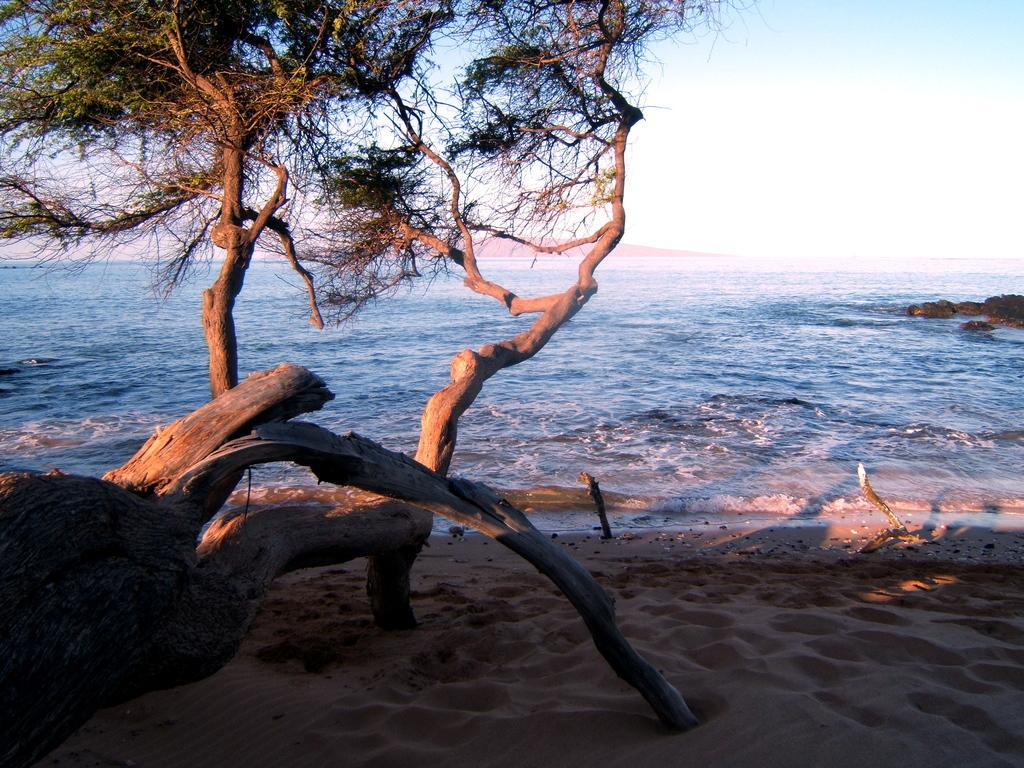What type of vegetation can be seen in the image? There are trees in the image. What type of ground is visible in the image? The ground is sand. What else can be seen in the image besides trees and sand? There is water visible in the image. What is visible in the background of the image? The sky is visible in the background of the image. Where is the jewel located in the image? There is no jewel present in the image. Can you see anyone skating on the sand in the image? There is no one skating in the image; it only shows trees, sand, water, and the sky. 